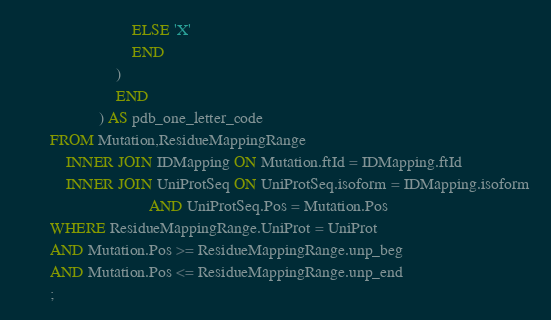Convert code to text. <code><loc_0><loc_0><loc_500><loc_500><_SQL_>                            ELSE 'X'
                            END
                        )
                        END
                    ) AS pdb_one_letter_code
        FROM Mutation,ResidueMappingRange
            INNER JOIN IDMapping ON Mutation.ftId = IDMapping.ftId
            INNER JOIN UniProtSeq ON UniProtSeq.isoform = IDMapping.isoform 
                                AND UniProtSeq.Pos = Mutation.Pos 
        WHERE ResidueMappingRange.UniProt = UniProt
        AND Mutation.Pos >= ResidueMappingRange.unp_beg
        AND Mutation.Pos <= ResidueMappingRange.unp_end
        ;</code> 